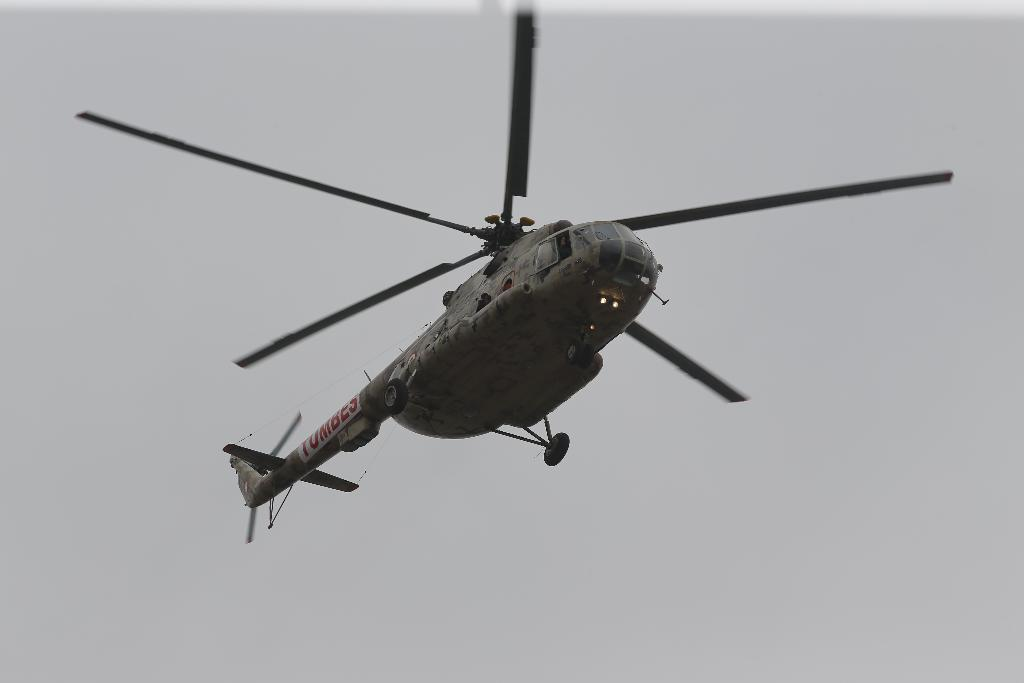What is the main subject of the image? The main subject of the image is a helicopter. What is the helicopter doing in the image? The helicopter is flying in the air. What type of destruction can be seen on the wall in the image? There is no wall present in the image, and therefore no destruction can be observed. What type of rake is being used to clear debris in the image? There is no rake or debris present in the image. 